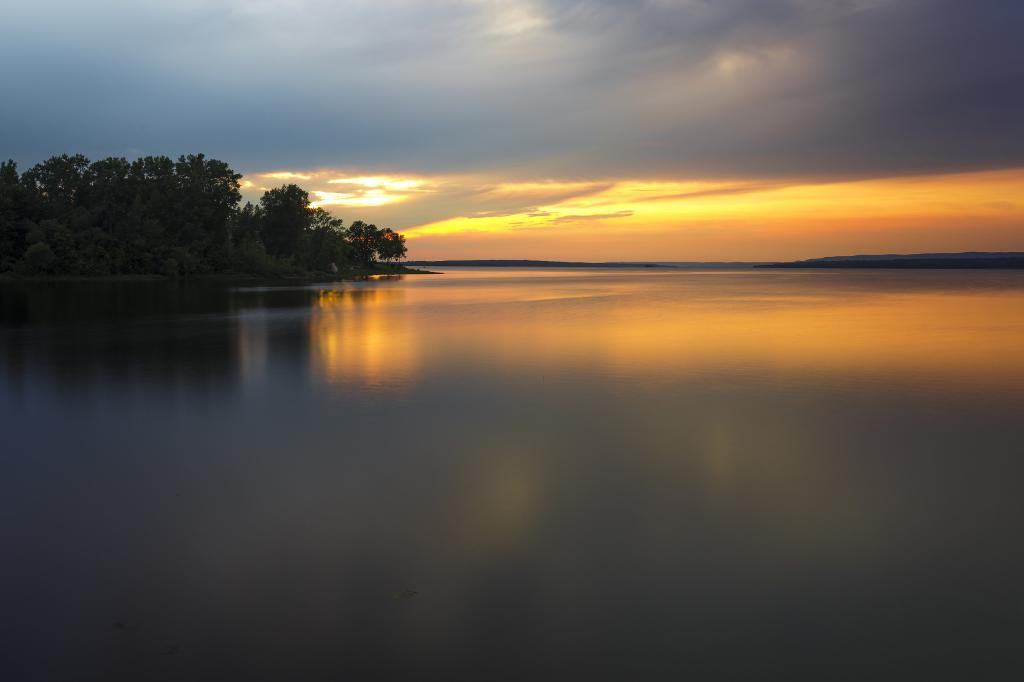What type of vegetation can be seen in the image? There are trees in the image. What natural element is visible alongside the trees? There is water visible in the image. What can be seen in the background of the image? The sky is visible in the background of the image. What is the condition of the sky in the image? Clouds are present in the sky. What type of wire is being used to grow the trees in the image? There is no wire present in the image; the trees are growing naturally. What seeds are being used to grow the trees in the image? The image does not show any seeds being used to grow the trees; it only shows the trees themselves. 